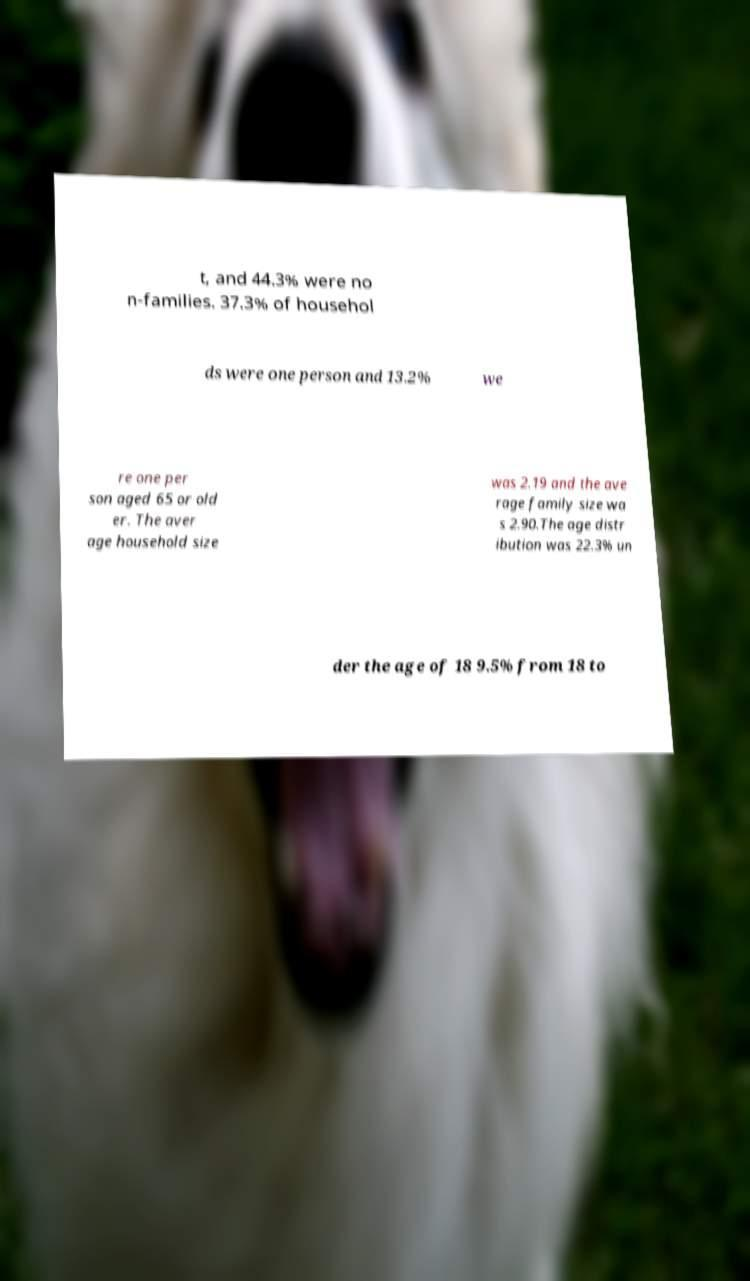Could you extract and type out the text from this image? t, and 44.3% were no n-families. 37.3% of househol ds were one person and 13.2% we re one per son aged 65 or old er. The aver age household size was 2.19 and the ave rage family size wa s 2.90.The age distr ibution was 22.3% un der the age of 18 9.5% from 18 to 